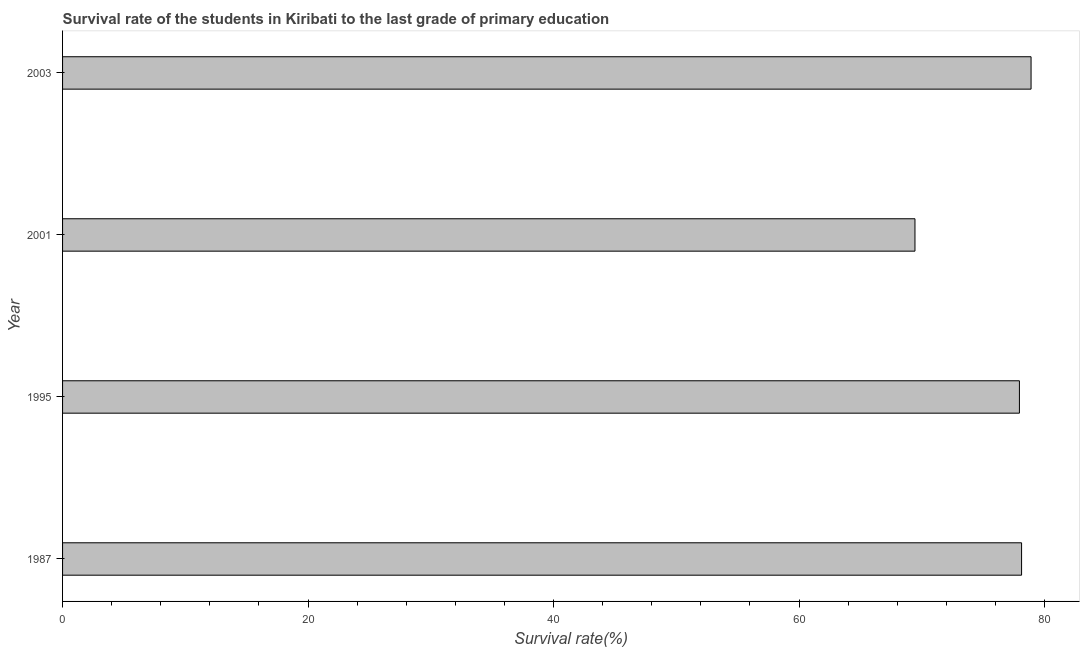Does the graph contain any zero values?
Provide a short and direct response. No. Does the graph contain grids?
Provide a succinct answer. No. What is the title of the graph?
Give a very brief answer. Survival rate of the students in Kiribati to the last grade of primary education. What is the label or title of the X-axis?
Provide a short and direct response. Survival rate(%). What is the label or title of the Y-axis?
Provide a succinct answer. Year. What is the survival rate in primary education in 2003?
Provide a short and direct response. 78.91. Across all years, what is the maximum survival rate in primary education?
Your response must be concise. 78.91. Across all years, what is the minimum survival rate in primary education?
Your response must be concise. 69.45. In which year was the survival rate in primary education minimum?
Provide a succinct answer. 2001. What is the sum of the survival rate in primary education?
Make the answer very short. 304.44. What is the difference between the survival rate in primary education in 1987 and 2001?
Offer a very short reply. 8.69. What is the average survival rate in primary education per year?
Ensure brevity in your answer.  76.11. What is the median survival rate in primary education?
Offer a terse response. 78.04. In how many years, is the survival rate in primary education greater than 52 %?
Ensure brevity in your answer.  4. Do a majority of the years between 1987 and 2001 (inclusive) have survival rate in primary education greater than 56 %?
Offer a very short reply. Yes. What is the difference between the highest and the second highest survival rate in primary education?
Keep it short and to the point. 0.77. Is the sum of the survival rate in primary education in 1987 and 2001 greater than the maximum survival rate in primary education across all years?
Your answer should be very brief. Yes. What is the difference between the highest and the lowest survival rate in primary education?
Offer a terse response. 9.46. In how many years, is the survival rate in primary education greater than the average survival rate in primary education taken over all years?
Give a very brief answer. 3. How many bars are there?
Ensure brevity in your answer.  4. Are all the bars in the graph horizontal?
Ensure brevity in your answer.  Yes. What is the difference between two consecutive major ticks on the X-axis?
Ensure brevity in your answer.  20. Are the values on the major ticks of X-axis written in scientific E-notation?
Provide a short and direct response. No. What is the Survival rate(%) in 1987?
Give a very brief answer. 78.13. What is the Survival rate(%) in 1995?
Keep it short and to the point. 77.96. What is the Survival rate(%) of 2001?
Your answer should be compact. 69.45. What is the Survival rate(%) in 2003?
Offer a terse response. 78.91. What is the difference between the Survival rate(%) in 1987 and 1995?
Offer a very short reply. 0.18. What is the difference between the Survival rate(%) in 1987 and 2001?
Offer a terse response. 8.69. What is the difference between the Survival rate(%) in 1987 and 2003?
Your answer should be very brief. -0.77. What is the difference between the Survival rate(%) in 1995 and 2001?
Offer a terse response. 8.51. What is the difference between the Survival rate(%) in 1995 and 2003?
Keep it short and to the point. -0.95. What is the difference between the Survival rate(%) in 2001 and 2003?
Offer a very short reply. -9.46. What is the ratio of the Survival rate(%) in 1987 to that in 1995?
Provide a succinct answer. 1. What is the ratio of the Survival rate(%) in 1987 to that in 2003?
Offer a terse response. 0.99. What is the ratio of the Survival rate(%) in 1995 to that in 2001?
Provide a short and direct response. 1.12. 